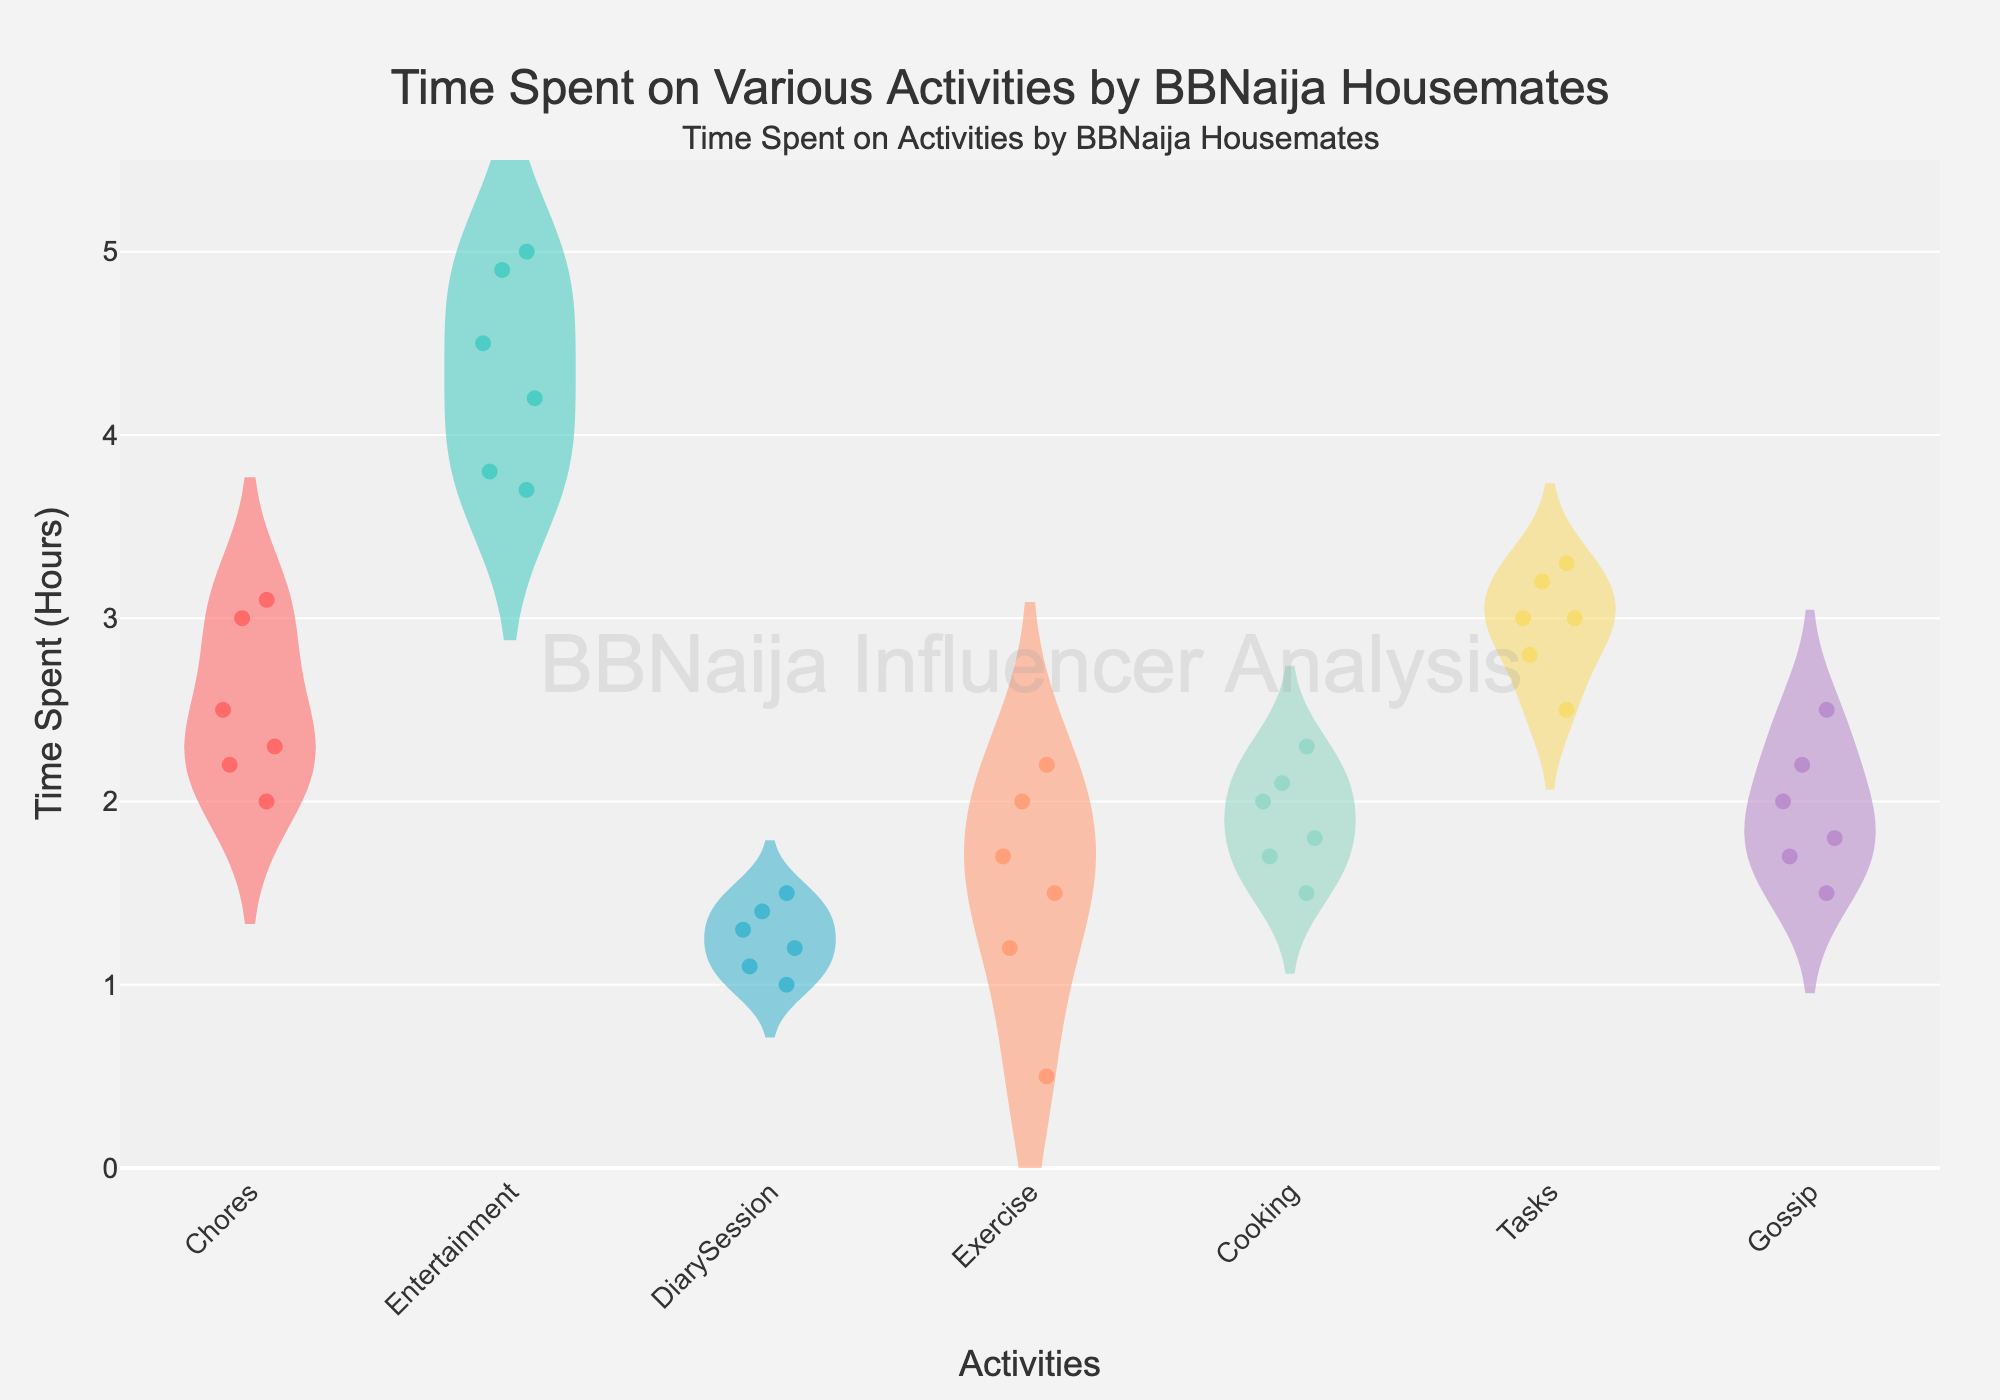What is the title of the figure? The title is located at the top of the figure and it reads: "Time Spent on Various Activities by BBNaija Housemates".
Answer: Time Spent on Various Activities by BBNaija Housemates What is the color used for the 'Entertainment' activity? The violin plot for each activity is denoted with separate colors. The specific color for 'Entertainment' activity can be noted.
Answer: '#4ECDC4' Which housemate spends the most time on 'Exercise'? Each housemate’s time spent on activities is visualized with points in the violin plot. Observing 'Exercise' we can determine the highest value.
Answer: Neo How many activities are represented in the figure? Each bar in the X-axis represents an activity. Counting each distinct activity provides the total count.
Answer: 6 What is the median value of time spent on 'Chores'? The median line of the violin plot for 'Chores' indicates the median time. You can see it in the central box part of the plot.
Answer: 2.5 hours Who spends the least time on 'DiarySession'? The lowest jittered point on the 'DiarySession' violin plot represents the minimum time spent.
Answer: Neo Which activity has the widest range in time spent by housemates? By comparing the height of the violin plots, the one with the most extended range from bottom to top represents the widest range.
Answer: Entertainment On average, how much time do housemates spend on 'Cooking'? By adding the times spent on 'Cooking' by all housemates and dividing by the number of housemates, the average can be calculated. (2.0 + 1.7 + 2.1 + 1.5 + 1.8 + 2.3) / 6 = 1.9
Answer: 1.9 hours Compare the mean time spent on 'Gossip' to 'Tasks'. Which one is higher? The mean is visible as a line within each violin plot. By observing both the 'Gossip' and 'Tasks' plots, we can identify the higher mean.
Answer: Tasks Which activity shows the most variability in time spent among housemates? The variability can be deduced by observing the spread of points within the violin plots. The more spread out the points, the greater the variability.
Answer: Entertainment 